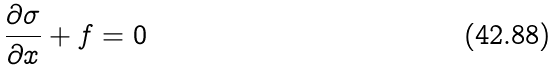<formula> <loc_0><loc_0><loc_500><loc_500>\frac { \partial \sigma } { \partial x } + f = 0</formula> 